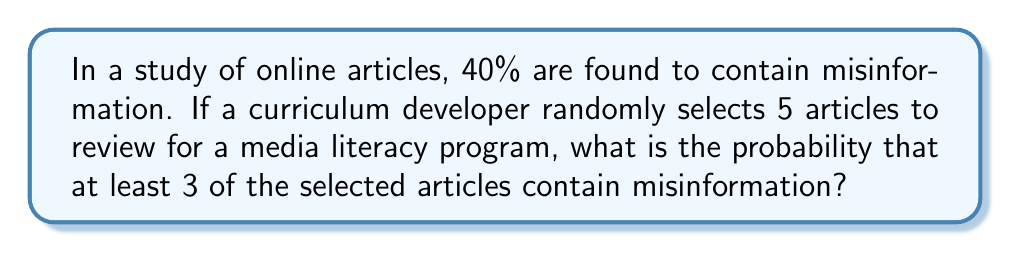Can you answer this question? To solve this problem, we'll use the binomial probability formula and the concept of cumulative probability.

Step 1: Define the parameters
n = 5 (number of articles selected)
p = 0.40 (probability of an article containing misinformation)
q = 1 - p = 0.60 (probability of an article not containing misinformation)

Step 2: Calculate the probability of exactly 3, 4, and 5 articles containing misinformation

For 3 articles:
$$P(X=3) = \binom{5}{3} \cdot 0.40^3 \cdot 0.60^2 = 10 \cdot 0.064 \cdot 0.36 = 0.2304$$

For 4 articles:
$$P(X=4) = \binom{5}{4} \cdot 0.40^4 \cdot 0.60^1 = 5 \cdot 0.0256 \cdot 0.60 = 0.0768$$

For 5 articles:
$$P(X=5) = \binom{5}{5} \cdot 0.40^5 \cdot 0.60^0 = 1 \cdot 0.01024 \cdot 1 = 0.01024$$

Step 3: Sum the probabilities to find the probability of at least 3 articles containing misinformation

$$P(X \geq 3) = P(X=3) + P(X=4) + P(X=5)$$
$$P(X \geq 3) = 0.2304 + 0.0768 + 0.01024 = 0.31744$$

Step 4: Convert to a percentage
0.31744 * 100 = 31.744%
Answer: 31.744% 